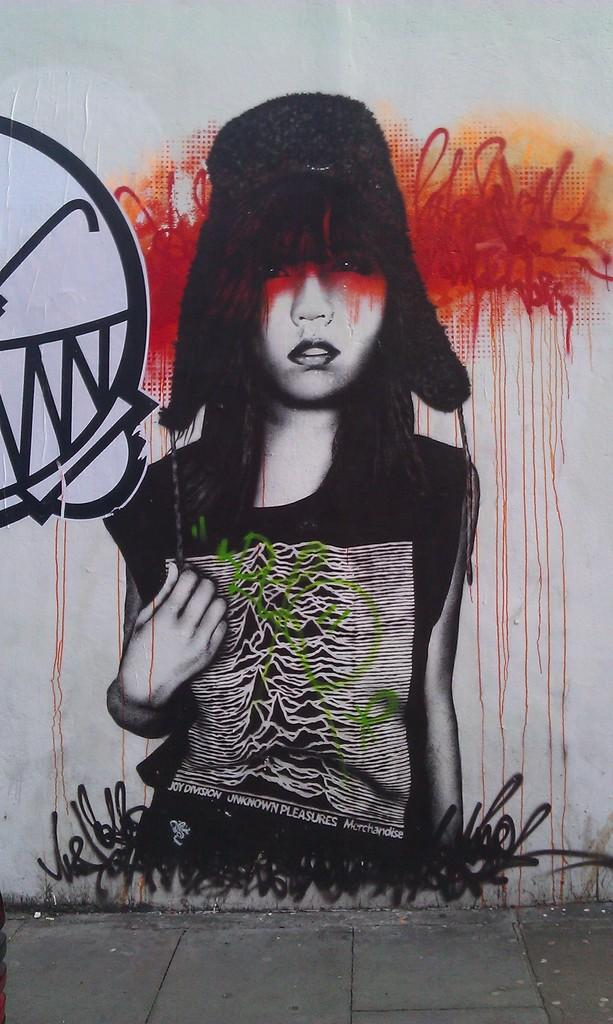What type of artwork can be seen in the picture? There is graffiti in the picture. What is visible at the bottom of the picture? The pavement is visible at the bottom of the picture. What is the color of the wall in the background of the picture? There is a white wall in the background of the picture. How many snails can be seen crawling on the graffiti in the image? There are no snails present in the image; it only features graffiti, pavement, and a white wall in the background. 